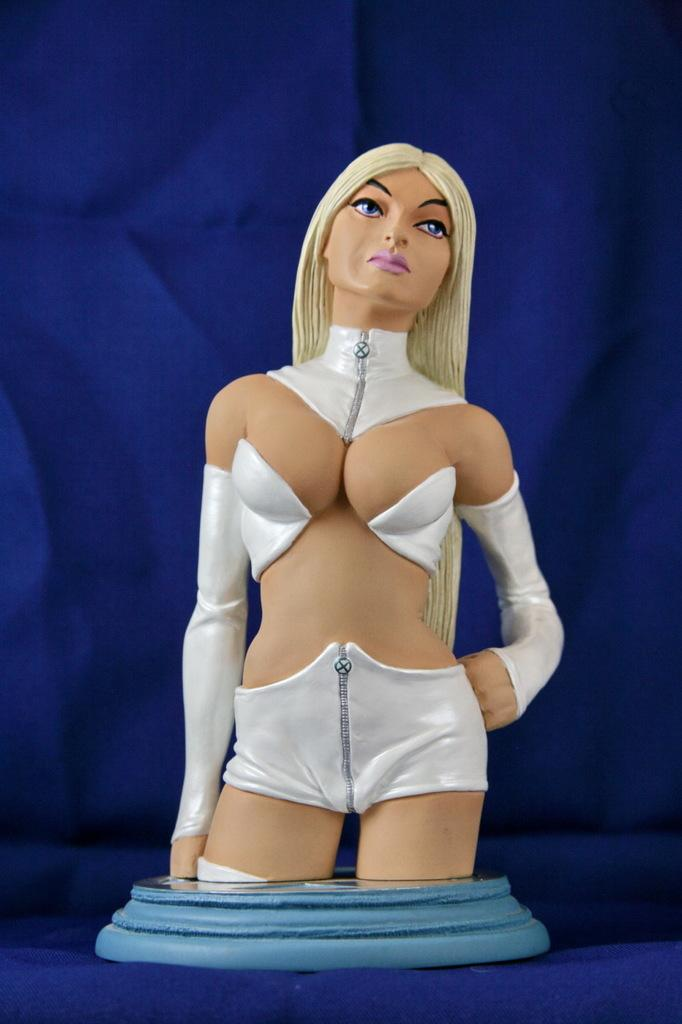What is the main subject of the image? There is a sculpture of a woman in the image. What can be observed about the woman in the sculpture? The woman in the sculpture is wearing clothes. What color is the background of the image? The background of the image is blue. How much credit does the woman in the sculpture have in the image? There is no mention of credit or financial matters in the image, as it features a sculpture of a woman. 